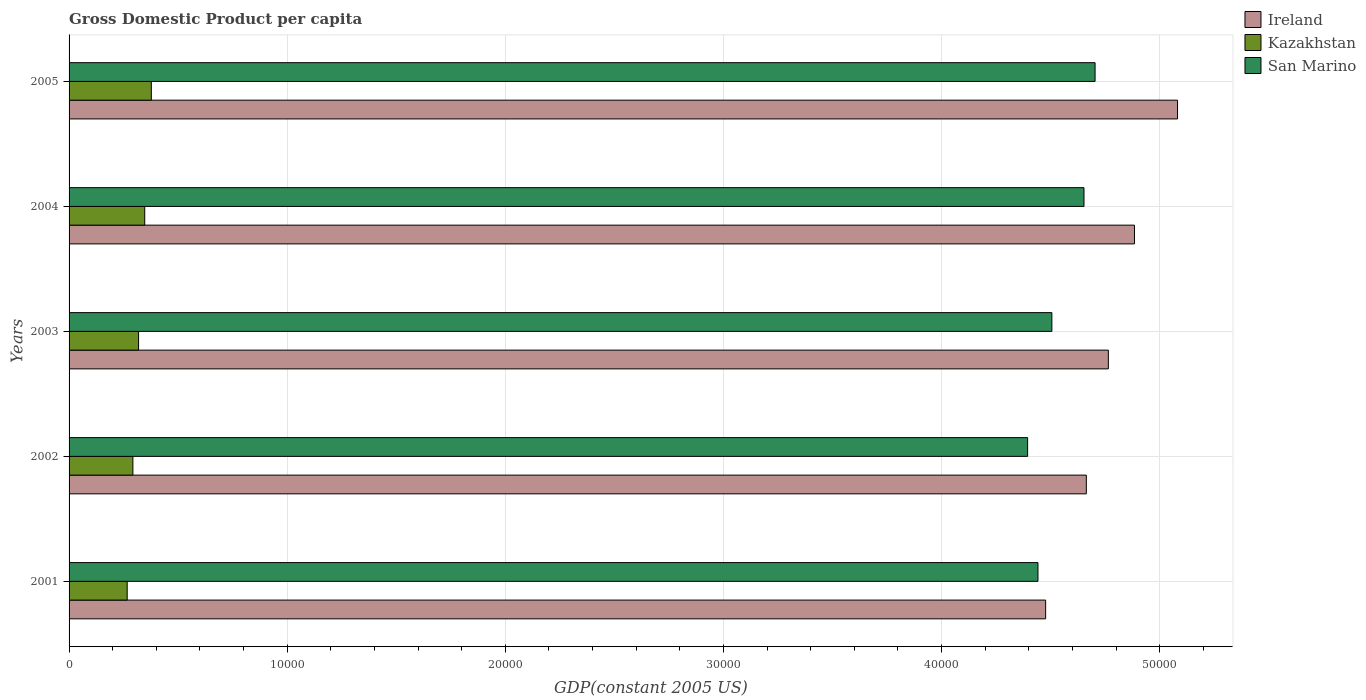How many groups of bars are there?
Give a very brief answer. 5. Are the number of bars per tick equal to the number of legend labels?
Provide a short and direct response. Yes. What is the label of the 4th group of bars from the top?
Give a very brief answer. 2002. What is the GDP per capita in San Marino in 2001?
Your answer should be compact. 4.44e+04. Across all years, what is the maximum GDP per capita in San Marino?
Keep it short and to the point. 4.70e+04. Across all years, what is the minimum GDP per capita in Ireland?
Your response must be concise. 4.48e+04. In which year was the GDP per capita in Kazakhstan minimum?
Your response must be concise. 2001. What is the total GDP per capita in San Marino in the graph?
Ensure brevity in your answer.  2.27e+05. What is the difference between the GDP per capita in San Marino in 2002 and that in 2005?
Your answer should be very brief. -3093.24. What is the difference between the GDP per capita in San Marino in 2005 and the GDP per capita in Ireland in 2003?
Your answer should be compact. -608.01. What is the average GDP per capita in San Marino per year?
Provide a short and direct response. 4.54e+04. In the year 2004, what is the difference between the GDP per capita in Kazakhstan and GDP per capita in Ireland?
Provide a short and direct response. -4.54e+04. What is the ratio of the GDP per capita in Ireland in 2003 to that in 2005?
Your response must be concise. 0.94. Is the GDP per capita in Kazakhstan in 2003 less than that in 2004?
Offer a terse response. Yes. Is the difference between the GDP per capita in Kazakhstan in 2001 and 2004 greater than the difference between the GDP per capita in Ireland in 2001 and 2004?
Provide a succinct answer. Yes. What is the difference between the highest and the second highest GDP per capita in Kazakhstan?
Offer a terse response. 302.77. What is the difference between the highest and the lowest GDP per capita in Kazakhstan?
Make the answer very short. 1106.84. In how many years, is the GDP per capita in Ireland greater than the average GDP per capita in Ireland taken over all years?
Ensure brevity in your answer.  2. Is the sum of the GDP per capita in Ireland in 2001 and 2003 greater than the maximum GDP per capita in Kazakhstan across all years?
Your answer should be very brief. Yes. What does the 1st bar from the top in 2001 represents?
Give a very brief answer. San Marino. What does the 3rd bar from the bottom in 2002 represents?
Ensure brevity in your answer.  San Marino. Is it the case that in every year, the sum of the GDP per capita in Ireland and GDP per capita in San Marino is greater than the GDP per capita in Kazakhstan?
Provide a short and direct response. Yes. How many bars are there?
Offer a very short reply. 15. What is the difference between two consecutive major ticks on the X-axis?
Your answer should be compact. 10000. Are the values on the major ticks of X-axis written in scientific E-notation?
Keep it short and to the point. No. Does the graph contain grids?
Provide a succinct answer. Yes. How many legend labels are there?
Keep it short and to the point. 3. How are the legend labels stacked?
Your response must be concise. Vertical. What is the title of the graph?
Keep it short and to the point. Gross Domestic Product per capita. Does "Moldova" appear as one of the legend labels in the graph?
Offer a very short reply. No. What is the label or title of the X-axis?
Give a very brief answer. GDP(constant 2005 US). What is the label or title of the Y-axis?
Keep it short and to the point. Years. What is the GDP(constant 2005 US) of Ireland in 2001?
Provide a succinct answer. 4.48e+04. What is the GDP(constant 2005 US) in Kazakhstan in 2001?
Ensure brevity in your answer.  2664.44. What is the GDP(constant 2005 US) of San Marino in 2001?
Your answer should be very brief. 4.44e+04. What is the GDP(constant 2005 US) of Ireland in 2002?
Give a very brief answer. 4.66e+04. What is the GDP(constant 2005 US) in Kazakhstan in 2002?
Offer a very short reply. 2925.44. What is the GDP(constant 2005 US) in San Marino in 2002?
Your response must be concise. 4.39e+04. What is the GDP(constant 2005 US) in Ireland in 2003?
Your answer should be very brief. 4.76e+04. What is the GDP(constant 2005 US) in Kazakhstan in 2003?
Make the answer very short. 3186.76. What is the GDP(constant 2005 US) of San Marino in 2003?
Keep it short and to the point. 4.51e+04. What is the GDP(constant 2005 US) in Ireland in 2004?
Keep it short and to the point. 4.88e+04. What is the GDP(constant 2005 US) of Kazakhstan in 2004?
Make the answer very short. 3468.51. What is the GDP(constant 2005 US) of San Marino in 2004?
Offer a terse response. 4.65e+04. What is the GDP(constant 2005 US) in Ireland in 2005?
Make the answer very short. 5.08e+04. What is the GDP(constant 2005 US) of Kazakhstan in 2005?
Provide a short and direct response. 3771.28. What is the GDP(constant 2005 US) of San Marino in 2005?
Give a very brief answer. 4.70e+04. Across all years, what is the maximum GDP(constant 2005 US) of Ireland?
Keep it short and to the point. 5.08e+04. Across all years, what is the maximum GDP(constant 2005 US) in Kazakhstan?
Your answer should be compact. 3771.28. Across all years, what is the maximum GDP(constant 2005 US) of San Marino?
Offer a terse response. 4.70e+04. Across all years, what is the minimum GDP(constant 2005 US) of Ireland?
Your response must be concise. 4.48e+04. Across all years, what is the minimum GDP(constant 2005 US) of Kazakhstan?
Provide a succinct answer. 2664.44. Across all years, what is the minimum GDP(constant 2005 US) of San Marino?
Your response must be concise. 4.39e+04. What is the total GDP(constant 2005 US) in Ireland in the graph?
Ensure brevity in your answer.  2.39e+05. What is the total GDP(constant 2005 US) of Kazakhstan in the graph?
Keep it short and to the point. 1.60e+04. What is the total GDP(constant 2005 US) of San Marino in the graph?
Provide a short and direct response. 2.27e+05. What is the difference between the GDP(constant 2005 US) in Ireland in 2001 and that in 2002?
Your answer should be very brief. -1865.28. What is the difference between the GDP(constant 2005 US) of Kazakhstan in 2001 and that in 2002?
Make the answer very short. -260.99. What is the difference between the GDP(constant 2005 US) in San Marino in 2001 and that in 2002?
Give a very brief answer. 474.73. What is the difference between the GDP(constant 2005 US) in Ireland in 2001 and that in 2003?
Offer a terse response. -2874.61. What is the difference between the GDP(constant 2005 US) of Kazakhstan in 2001 and that in 2003?
Make the answer very short. -522.32. What is the difference between the GDP(constant 2005 US) in San Marino in 2001 and that in 2003?
Provide a succinct answer. -637.89. What is the difference between the GDP(constant 2005 US) of Ireland in 2001 and that in 2004?
Your answer should be very brief. -4072.2. What is the difference between the GDP(constant 2005 US) of Kazakhstan in 2001 and that in 2004?
Give a very brief answer. -804.06. What is the difference between the GDP(constant 2005 US) in San Marino in 2001 and that in 2004?
Give a very brief answer. -2110.42. What is the difference between the GDP(constant 2005 US) of Ireland in 2001 and that in 2005?
Provide a succinct answer. -6046.59. What is the difference between the GDP(constant 2005 US) in Kazakhstan in 2001 and that in 2005?
Offer a terse response. -1106.84. What is the difference between the GDP(constant 2005 US) of San Marino in 2001 and that in 2005?
Provide a short and direct response. -2618.51. What is the difference between the GDP(constant 2005 US) of Ireland in 2002 and that in 2003?
Make the answer very short. -1009.34. What is the difference between the GDP(constant 2005 US) of Kazakhstan in 2002 and that in 2003?
Your response must be concise. -261.33. What is the difference between the GDP(constant 2005 US) in San Marino in 2002 and that in 2003?
Your answer should be compact. -1112.63. What is the difference between the GDP(constant 2005 US) in Ireland in 2002 and that in 2004?
Ensure brevity in your answer.  -2206.92. What is the difference between the GDP(constant 2005 US) of Kazakhstan in 2002 and that in 2004?
Offer a very short reply. -543.07. What is the difference between the GDP(constant 2005 US) in San Marino in 2002 and that in 2004?
Give a very brief answer. -2585.16. What is the difference between the GDP(constant 2005 US) of Ireland in 2002 and that in 2005?
Your answer should be very brief. -4181.31. What is the difference between the GDP(constant 2005 US) of Kazakhstan in 2002 and that in 2005?
Ensure brevity in your answer.  -845.84. What is the difference between the GDP(constant 2005 US) in San Marino in 2002 and that in 2005?
Offer a terse response. -3093.24. What is the difference between the GDP(constant 2005 US) in Ireland in 2003 and that in 2004?
Give a very brief answer. -1197.58. What is the difference between the GDP(constant 2005 US) of Kazakhstan in 2003 and that in 2004?
Keep it short and to the point. -281.74. What is the difference between the GDP(constant 2005 US) of San Marino in 2003 and that in 2004?
Offer a very short reply. -1472.53. What is the difference between the GDP(constant 2005 US) in Ireland in 2003 and that in 2005?
Provide a short and direct response. -3171.98. What is the difference between the GDP(constant 2005 US) of Kazakhstan in 2003 and that in 2005?
Keep it short and to the point. -584.51. What is the difference between the GDP(constant 2005 US) in San Marino in 2003 and that in 2005?
Make the answer very short. -1980.62. What is the difference between the GDP(constant 2005 US) in Ireland in 2004 and that in 2005?
Your answer should be very brief. -1974.4. What is the difference between the GDP(constant 2005 US) in Kazakhstan in 2004 and that in 2005?
Your answer should be compact. -302.77. What is the difference between the GDP(constant 2005 US) in San Marino in 2004 and that in 2005?
Your answer should be compact. -508.08. What is the difference between the GDP(constant 2005 US) of Ireland in 2001 and the GDP(constant 2005 US) of Kazakhstan in 2002?
Offer a very short reply. 4.18e+04. What is the difference between the GDP(constant 2005 US) of Ireland in 2001 and the GDP(constant 2005 US) of San Marino in 2002?
Ensure brevity in your answer.  826.64. What is the difference between the GDP(constant 2005 US) of Kazakhstan in 2001 and the GDP(constant 2005 US) of San Marino in 2002?
Make the answer very short. -4.13e+04. What is the difference between the GDP(constant 2005 US) of Ireland in 2001 and the GDP(constant 2005 US) of Kazakhstan in 2003?
Keep it short and to the point. 4.16e+04. What is the difference between the GDP(constant 2005 US) of Ireland in 2001 and the GDP(constant 2005 US) of San Marino in 2003?
Ensure brevity in your answer.  -285.99. What is the difference between the GDP(constant 2005 US) of Kazakhstan in 2001 and the GDP(constant 2005 US) of San Marino in 2003?
Your answer should be compact. -4.24e+04. What is the difference between the GDP(constant 2005 US) of Ireland in 2001 and the GDP(constant 2005 US) of Kazakhstan in 2004?
Offer a very short reply. 4.13e+04. What is the difference between the GDP(constant 2005 US) in Ireland in 2001 and the GDP(constant 2005 US) in San Marino in 2004?
Your response must be concise. -1758.52. What is the difference between the GDP(constant 2005 US) in Kazakhstan in 2001 and the GDP(constant 2005 US) in San Marino in 2004?
Give a very brief answer. -4.39e+04. What is the difference between the GDP(constant 2005 US) of Ireland in 2001 and the GDP(constant 2005 US) of Kazakhstan in 2005?
Offer a terse response. 4.10e+04. What is the difference between the GDP(constant 2005 US) in Ireland in 2001 and the GDP(constant 2005 US) in San Marino in 2005?
Offer a very short reply. -2266.6. What is the difference between the GDP(constant 2005 US) in Kazakhstan in 2001 and the GDP(constant 2005 US) in San Marino in 2005?
Your answer should be compact. -4.44e+04. What is the difference between the GDP(constant 2005 US) in Ireland in 2002 and the GDP(constant 2005 US) in Kazakhstan in 2003?
Your answer should be very brief. 4.34e+04. What is the difference between the GDP(constant 2005 US) of Ireland in 2002 and the GDP(constant 2005 US) of San Marino in 2003?
Ensure brevity in your answer.  1579.29. What is the difference between the GDP(constant 2005 US) in Kazakhstan in 2002 and the GDP(constant 2005 US) in San Marino in 2003?
Your answer should be very brief. -4.21e+04. What is the difference between the GDP(constant 2005 US) of Ireland in 2002 and the GDP(constant 2005 US) of Kazakhstan in 2004?
Your answer should be compact. 4.32e+04. What is the difference between the GDP(constant 2005 US) of Ireland in 2002 and the GDP(constant 2005 US) of San Marino in 2004?
Provide a short and direct response. 106.76. What is the difference between the GDP(constant 2005 US) in Kazakhstan in 2002 and the GDP(constant 2005 US) in San Marino in 2004?
Provide a succinct answer. -4.36e+04. What is the difference between the GDP(constant 2005 US) in Ireland in 2002 and the GDP(constant 2005 US) in Kazakhstan in 2005?
Your answer should be compact. 4.29e+04. What is the difference between the GDP(constant 2005 US) of Ireland in 2002 and the GDP(constant 2005 US) of San Marino in 2005?
Offer a very short reply. -401.32. What is the difference between the GDP(constant 2005 US) of Kazakhstan in 2002 and the GDP(constant 2005 US) of San Marino in 2005?
Your answer should be very brief. -4.41e+04. What is the difference between the GDP(constant 2005 US) of Ireland in 2003 and the GDP(constant 2005 US) of Kazakhstan in 2004?
Your answer should be very brief. 4.42e+04. What is the difference between the GDP(constant 2005 US) of Ireland in 2003 and the GDP(constant 2005 US) of San Marino in 2004?
Offer a terse response. 1116.09. What is the difference between the GDP(constant 2005 US) in Kazakhstan in 2003 and the GDP(constant 2005 US) in San Marino in 2004?
Your answer should be compact. -4.33e+04. What is the difference between the GDP(constant 2005 US) in Ireland in 2003 and the GDP(constant 2005 US) in Kazakhstan in 2005?
Your answer should be very brief. 4.39e+04. What is the difference between the GDP(constant 2005 US) of Ireland in 2003 and the GDP(constant 2005 US) of San Marino in 2005?
Your answer should be very brief. 608.01. What is the difference between the GDP(constant 2005 US) in Kazakhstan in 2003 and the GDP(constant 2005 US) in San Marino in 2005?
Make the answer very short. -4.38e+04. What is the difference between the GDP(constant 2005 US) in Ireland in 2004 and the GDP(constant 2005 US) in Kazakhstan in 2005?
Make the answer very short. 4.51e+04. What is the difference between the GDP(constant 2005 US) of Ireland in 2004 and the GDP(constant 2005 US) of San Marino in 2005?
Ensure brevity in your answer.  1805.59. What is the difference between the GDP(constant 2005 US) of Kazakhstan in 2004 and the GDP(constant 2005 US) of San Marino in 2005?
Provide a succinct answer. -4.36e+04. What is the average GDP(constant 2005 US) in Ireland per year?
Ensure brevity in your answer.  4.77e+04. What is the average GDP(constant 2005 US) in Kazakhstan per year?
Ensure brevity in your answer.  3203.29. What is the average GDP(constant 2005 US) in San Marino per year?
Ensure brevity in your answer.  4.54e+04. In the year 2001, what is the difference between the GDP(constant 2005 US) of Ireland and GDP(constant 2005 US) of Kazakhstan?
Ensure brevity in your answer.  4.21e+04. In the year 2001, what is the difference between the GDP(constant 2005 US) in Ireland and GDP(constant 2005 US) in San Marino?
Ensure brevity in your answer.  351.91. In the year 2001, what is the difference between the GDP(constant 2005 US) of Kazakhstan and GDP(constant 2005 US) of San Marino?
Provide a short and direct response. -4.18e+04. In the year 2002, what is the difference between the GDP(constant 2005 US) of Ireland and GDP(constant 2005 US) of Kazakhstan?
Offer a terse response. 4.37e+04. In the year 2002, what is the difference between the GDP(constant 2005 US) of Ireland and GDP(constant 2005 US) of San Marino?
Offer a terse response. 2691.92. In the year 2002, what is the difference between the GDP(constant 2005 US) in Kazakhstan and GDP(constant 2005 US) in San Marino?
Offer a terse response. -4.10e+04. In the year 2003, what is the difference between the GDP(constant 2005 US) in Ireland and GDP(constant 2005 US) in Kazakhstan?
Your answer should be very brief. 4.45e+04. In the year 2003, what is the difference between the GDP(constant 2005 US) in Ireland and GDP(constant 2005 US) in San Marino?
Your response must be concise. 2588.63. In the year 2003, what is the difference between the GDP(constant 2005 US) of Kazakhstan and GDP(constant 2005 US) of San Marino?
Your response must be concise. -4.19e+04. In the year 2004, what is the difference between the GDP(constant 2005 US) in Ireland and GDP(constant 2005 US) in Kazakhstan?
Give a very brief answer. 4.54e+04. In the year 2004, what is the difference between the GDP(constant 2005 US) in Ireland and GDP(constant 2005 US) in San Marino?
Your answer should be very brief. 2313.68. In the year 2004, what is the difference between the GDP(constant 2005 US) in Kazakhstan and GDP(constant 2005 US) in San Marino?
Your response must be concise. -4.31e+04. In the year 2005, what is the difference between the GDP(constant 2005 US) of Ireland and GDP(constant 2005 US) of Kazakhstan?
Provide a short and direct response. 4.70e+04. In the year 2005, what is the difference between the GDP(constant 2005 US) of Ireland and GDP(constant 2005 US) of San Marino?
Your response must be concise. 3779.99. In the year 2005, what is the difference between the GDP(constant 2005 US) of Kazakhstan and GDP(constant 2005 US) of San Marino?
Your answer should be compact. -4.33e+04. What is the ratio of the GDP(constant 2005 US) in Kazakhstan in 2001 to that in 2002?
Offer a terse response. 0.91. What is the ratio of the GDP(constant 2005 US) of San Marino in 2001 to that in 2002?
Give a very brief answer. 1.01. What is the ratio of the GDP(constant 2005 US) of Ireland in 2001 to that in 2003?
Offer a terse response. 0.94. What is the ratio of the GDP(constant 2005 US) in Kazakhstan in 2001 to that in 2003?
Provide a short and direct response. 0.84. What is the ratio of the GDP(constant 2005 US) in San Marino in 2001 to that in 2003?
Offer a terse response. 0.99. What is the ratio of the GDP(constant 2005 US) in Ireland in 2001 to that in 2004?
Your answer should be compact. 0.92. What is the ratio of the GDP(constant 2005 US) of Kazakhstan in 2001 to that in 2004?
Offer a terse response. 0.77. What is the ratio of the GDP(constant 2005 US) of San Marino in 2001 to that in 2004?
Offer a terse response. 0.95. What is the ratio of the GDP(constant 2005 US) of Ireland in 2001 to that in 2005?
Your response must be concise. 0.88. What is the ratio of the GDP(constant 2005 US) of Kazakhstan in 2001 to that in 2005?
Ensure brevity in your answer.  0.71. What is the ratio of the GDP(constant 2005 US) of San Marino in 2001 to that in 2005?
Ensure brevity in your answer.  0.94. What is the ratio of the GDP(constant 2005 US) in Ireland in 2002 to that in 2003?
Offer a terse response. 0.98. What is the ratio of the GDP(constant 2005 US) of Kazakhstan in 2002 to that in 2003?
Your response must be concise. 0.92. What is the ratio of the GDP(constant 2005 US) in San Marino in 2002 to that in 2003?
Your answer should be compact. 0.98. What is the ratio of the GDP(constant 2005 US) of Ireland in 2002 to that in 2004?
Make the answer very short. 0.95. What is the ratio of the GDP(constant 2005 US) in Kazakhstan in 2002 to that in 2004?
Your response must be concise. 0.84. What is the ratio of the GDP(constant 2005 US) of San Marino in 2002 to that in 2004?
Offer a terse response. 0.94. What is the ratio of the GDP(constant 2005 US) of Ireland in 2002 to that in 2005?
Provide a succinct answer. 0.92. What is the ratio of the GDP(constant 2005 US) of Kazakhstan in 2002 to that in 2005?
Give a very brief answer. 0.78. What is the ratio of the GDP(constant 2005 US) in San Marino in 2002 to that in 2005?
Provide a short and direct response. 0.93. What is the ratio of the GDP(constant 2005 US) of Ireland in 2003 to that in 2004?
Offer a terse response. 0.98. What is the ratio of the GDP(constant 2005 US) in Kazakhstan in 2003 to that in 2004?
Your response must be concise. 0.92. What is the ratio of the GDP(constant 2005 US) of San Marino in 2003 to that in 2004?
Keep it short and to the point. 0.97. What is the ratio of the GDP(constant 2005 US) of Ireland in 2003 to that in 2005?
Your answer should be compact. 0.94. What is the ratio of the GDP(constant 2005 US) in Kazakhstan in 2003 to that in 2005?
Give a very brief answer. 0.84. What is the ratio of the GDP(constant 2005 US) of San Marino in 2003 to that in 2005?
Offer a very short reply. 0.96. What is the ratio of the GDP(constant 2005 US) of Ireland in 2004 to that in 2005?
Offer a very short reply. 0.96. What is the ratio of the GDP(constant 2005 US) in Kazakhstan in 2004 to that in 2005?
Provide a short and direct response. 0.92. What is the ratio of the GDP(constant 2005 US) in San Marino in 2004 to that in 2005?
Ensure brevity in your answer.  0.99. What is the difference between the highest and the second highest GDP(constant 2005 US) of Ireland?
Provide a short and direct response. 1974.4. What is the difference between the highest and the second highest GDP(constant 2005 US) of Kazakhstan?
Your answer should be very brief. 302.77. What is the difference between the highest and the second highest GDP(constant 2005 US) in San Marino?
Give a very brief answer. 508.08. What is the difference between the highest and the lowest GDP(constant 2005 US) in Ireland?
Provide a succinct answer. 6046.59. What is the difference between the highest and the lowest GDP(constant 2005 US) in Kazakhstan?
Provide a short and direct response. 1106.84. What is the difference between the highest and the lowest GDP(constant 2005 US) in San Marino?
Provide a succinct answer. 3093.24. 